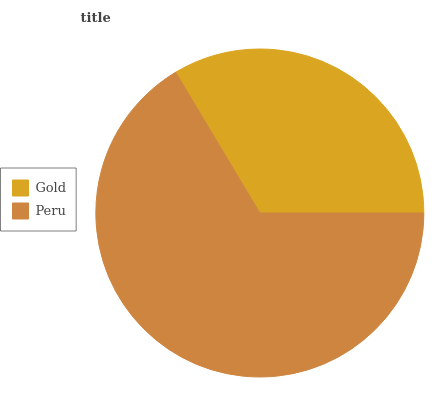Is Gold the minimum?
Answer yes or no. Yes. Is Peru the maximum?
Answer yes or no. Yes. Is Peru the minimum?
Answer yes or no. No. Is Peru greater than Gold?
Answer yes or no. Yes. Is Gold less than Peru?
Answer yes or no. Yes. Is Gold greater than Peru?
Answer yes or no. No. Is Peru less than Gold?
Answer yes or no. No. Is Peru the high median?
Answer yes or no. Yes. Is Gold the low median?
Answer yes or no. Yes. Is Gold the high median?
Answer yes or no. No. Is Peru the low median?
Answer yes or no. No. 